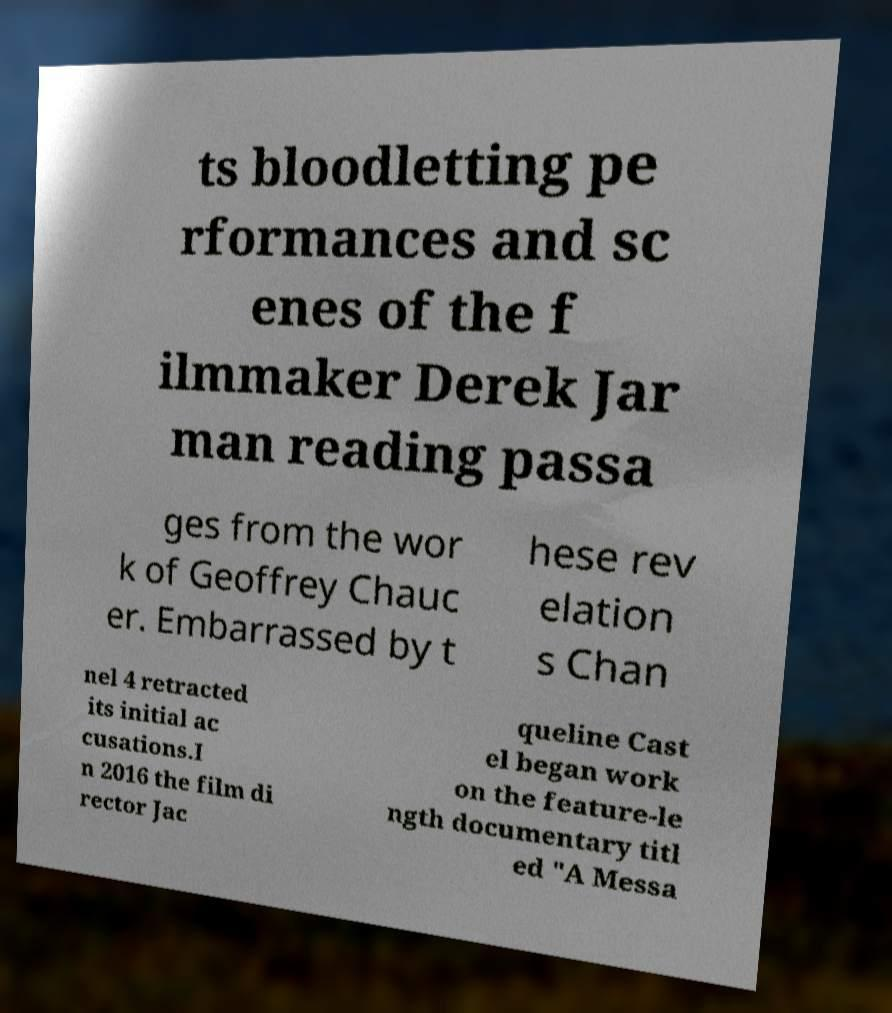Could you assist in decoding the text presented in this image and type it out clearly? ts bloodletting pe rformances and sc enes of the f ilmmaker Derek Jar man reading passa ges from the wor k of Geoffrey Chauc er. Embarrassed by t hese rev elation s Chan nel 4 retracted its initial ac cusations.I n 2016 the film di rector Jac queline Cast el began work on the feature-le ngth documentary titl ed "A Messa 